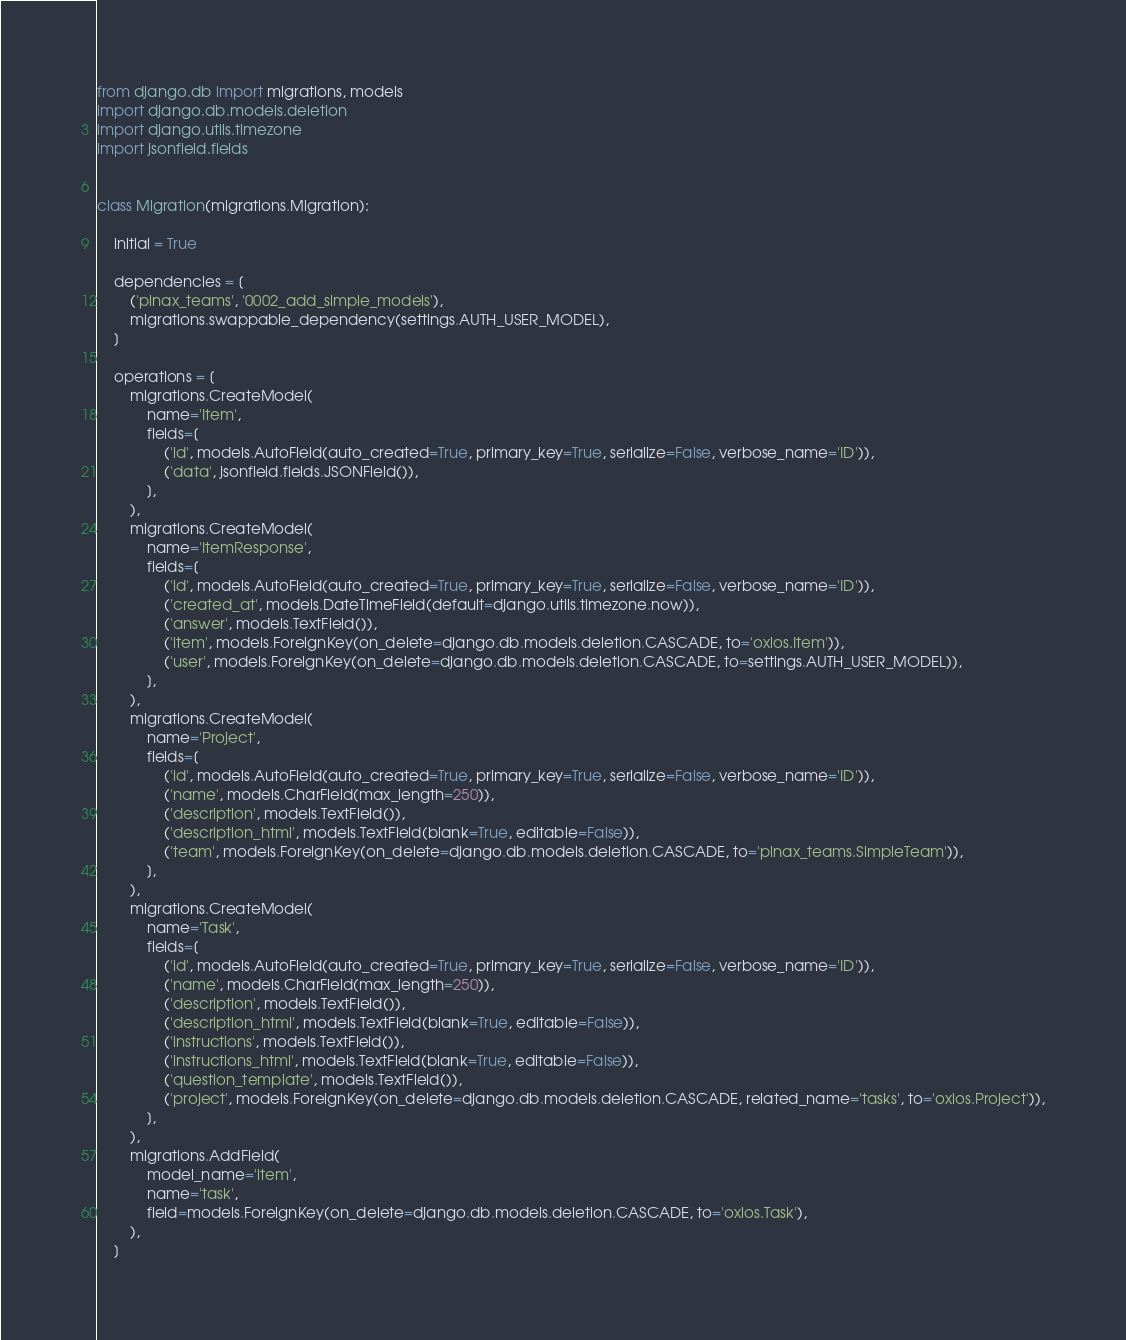<code> <loc_0><loc_0><loc_500><loc_500><_Python_>from django.db import migrations, models
import django.db.models.deletion
import django.utils.timezone
import jsonfield.fields


class Migration(migrations.Migration):

    initial = True

    dependencies = [
        ('pinax_teams', '0002_add_simple_models'),
        migrations.swappable_dependency(settings.AUTH_USER_MODEL),
    ]

    operations = [
        migrations.CreateModel(
            name='Item',
            fields=[
                ('id', models.AutoField(auto_created=True, primary_key=True, serialize=False, verbose_name='ID')),
                ('data', jsonfield.fields.JSONField()),
            ],
        ),
        migrations.CreateModel(
            name='ItemResponse',
            fields=[
                ('id', models.AutoField(auto_created=True, primary_key=True, serialize=False, verbose_name='ID')),
                ('created_at', models.DateTimeField(default=django.utils.timezone.now)),
                ('answer', models.TextField()),
                ('item', models.ForeignKey(on_delete=django.db.models.deletion.CASCADE, to='oxlos.Item')),
                ('user', models.ForeignKey(on_delete=django.db.models.deletion.CASCADE, to=settings.AUTH_USER_MODEL)),
            ],
        ),
        migrations.CreateModel(
            name='Project',
            fields=[
                ('id', models.AutoField(auto_created=True, primary_key=True, serialize=False, verbose_name='ID')),
                ('name', models.CharField(max_length=250)),
                ('description', models.TextField()),
                ('description_html', models.TextField(blank=True, editable=False)),
                ('team', models.ForeignKey(on_delete=django.db.models.deletion.CASCADE, to='pinax_teams.SimpleTeam')),
            ],
        ),
        migrations.CreateModel(
            name='Task',
            fields=[
                ('id', models.AutoField(auto_created=True, primary_key=True, serialize=False, verbose_name='ID')),
                ('name', models.CharField(max_length=250)),
                ('description', models.TextField()),
                ('description_html', models.TextField(blank=True, editable=False)),
                ('instructions', models.TextField()),
                ('instructions_html', models.TextField(blank=True, editable=False)),
                ('question_template', models.TextField()),
                ('project', models.ForeignKey(on_delete=django.db.models.deletion.CASCADE, related_name='tasks', to='oxlos.Project')),
            ],
        ),
        migrations.AddField(
            model_name='item',
            name='task',
            field=models.ForeignKey(on_delete=django.db.models.deletion.CASCADE, to='oxlos.Task'),
        ),
    ]
</code> 